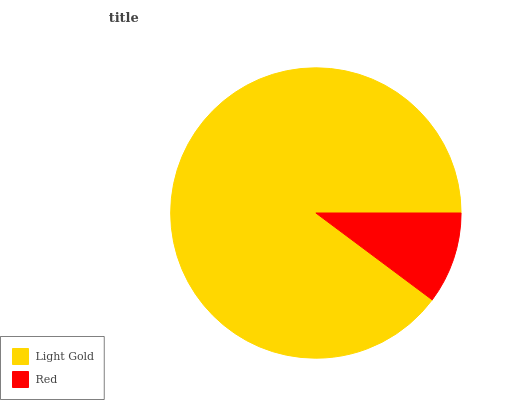Is Red the minimum?
Answer yes or no. Yes. Is Light Gold the maximum?
Answer yes or no. Yes. Is Red the maximum?
Answer yes or no. No. Is Light Gold greater than Red?
Answer yes or no. Yes. Is Red less than Light Gold?
Answer yes or no. Yes. Is Red greater than Light Gold?
Answer yes or no. No. Is Light Gold less than Red?
Answer yes or no. No. Is Light Gold the high median?
Answer yes or no. Yes. Is Red the low median?
Answer yes or no. Yes. Is Red the high median?
Answer yes or no. No. Is Light Gold the low median?
Answer yes or no. No. 